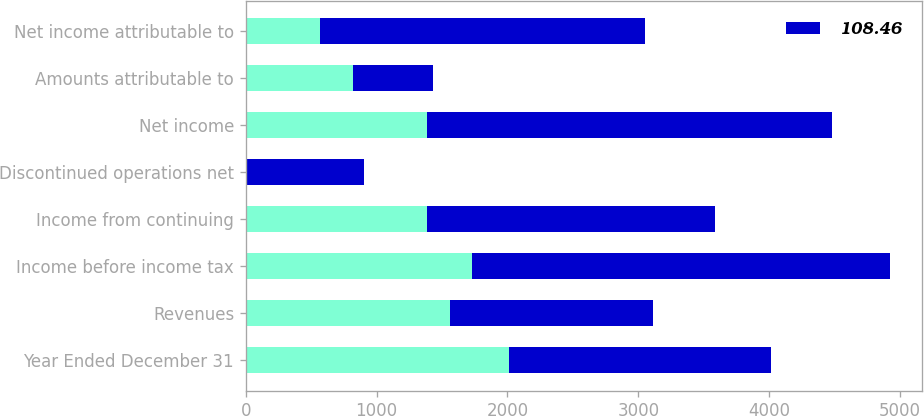Convert chart. <chart><loc_0><loc_0><loc_500><loc_500><stacked_bar_chart><ecel><fcel>Year Ended December 31<fcel>Revenues<fcel>Income before income tax<fcel>Income from continuing<fcel>Discontinued operations net<fcel>Net income<fcel>Amounts attributable to<fcel>Net income attributable to<nl><fcel>nan<fcel>2009<fcel>1557.5<fcel>1730<fcel>1385<fcel>2<fcel>1383<fcel>819<fcel>564<nl><fcel>108.46<fcel>2007<fcel>1557.5<fcel>3194<fcel>2199<fcel>901<fcel>3100<fcel>612<fcel>2488<nl></chart> 